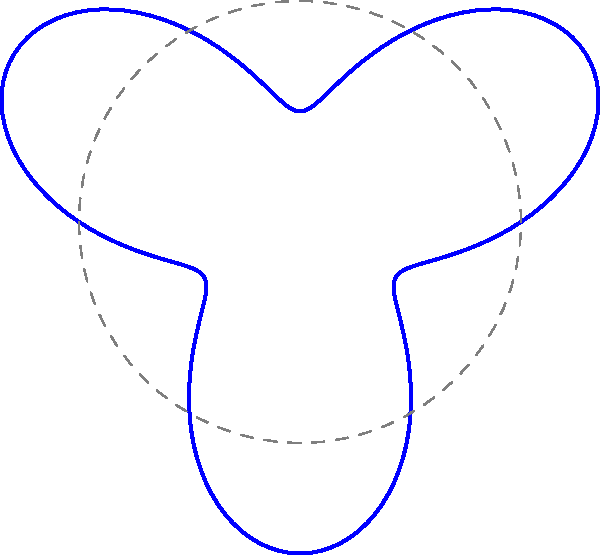In the polar graph representing the timeline and intensity of a high-profile trial over 60 days, where each complete revolution represents 30 days, and the distance from the center indicates the intensity of media coverage, at which point does the trial appear to have the highest media intensity? To determine the point of highest media intensity, we need to analyze the graph step-by-step:

1. The polar graph represents a 60-day trial timeline, with each complete revolution equal to 30 days.

2. The distance from the center indicates the intensity of media coverage.

3. The graph is created using the polar equation $r = 1 + 0.5\sin(3\theta)$, where $r$ is the radius (intensity) and $\theta$ is the angle (time).

4. We can see three labeled points on the graph: A, B, and C.

5. Point A is at Day 1, representing the start of the trial.

6. Point B is at Day 15, halfway through the first month.

7. Point C is approximately at Day 20, based on its position between Day 15 and Day 30.

8. By visually inspecting the graph, we can see that point B is farthest from the center.

9. This indicates that the media intensity reaches its peak at point B, which corresponds to Day 15 of the trial.

Therefore, the trial appears to have the highest media intensity at point B, which is Day 15.
Answer: Point B (Day 15) 